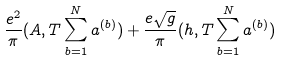<formula> <loc_0><loc_0><loc_500><loc_500>\frac { e ^ { 2 } } { \pi } ( A , T \sum _ { b = 1 } ^ { N } a ^ { ( b ) } ) + \frac { e \sqrt { g } } { \pi } ( h , T \sum _ { b = 1 } ^ { N } a ^ { ( b ) } )</formula> 